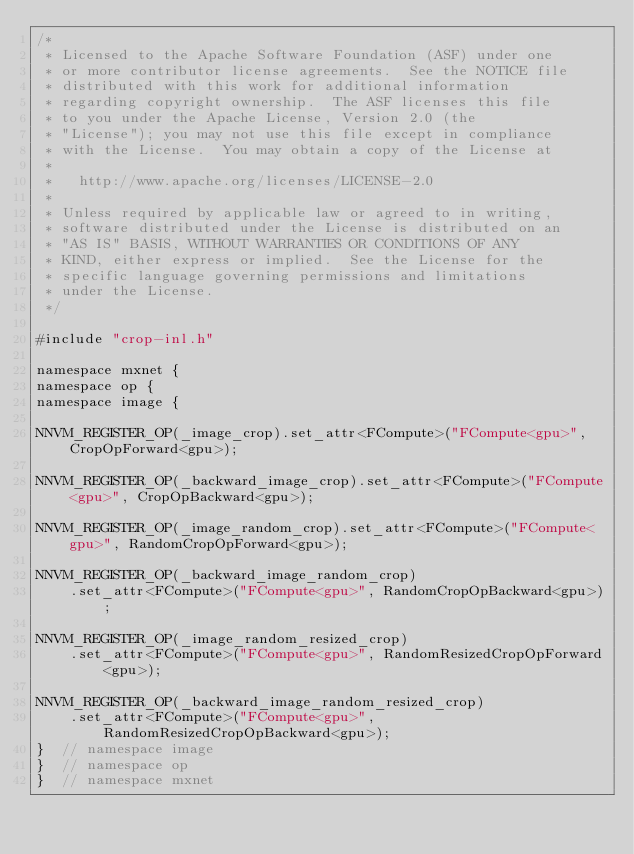<code> <loc_0><loc_0><loc_500><loc_500><_Cuda_>/*
 * Licensed to the Apache Software Foundation (ASF) under one
 * or more contributor license agreements.  See the NOTICE file
 * distributed with this work for additional information
 * regarding copyright ownership.  The ASF licenses this file
 * to you under the Apache License, Version 2.0 (the
 * "License"); you may not use this file except in compliance
 * with the License.  You may obtain a copy of the License at
 *
 *   http://www.apache.org/licenses/LICENSE-2.0
 *
 * Unless required by applicable law or agreed to in writing,
 * software distributed under the License is distributed on an
 * "AS IS" BASIS, WITHOUT WARRANTIES OR CONDITIONS OF ANY
 * KIND, either express or implied.  See the License for the
 * specific language governing permissions and limitations
 * under the License.
 */

#include "crop-inl.h"

namespace mxnet {
namespace op {
namespace image {

NNVM_REGISTER_OP(_image_crop).set_attr<FCompute>("FCompute<gpu>", CropOpForward<gpu>);

NNVM_REGISTER_OP(_backward_image_crop).set_attr<FCompute>("FCompute<gpu>", CropOpBackward<gpu>);

NNVM_REGISTER_OP(_image_random_crop).set_attr<FCompute>("FCompute<gpu>", RandomCropOpForward<gpu>);

NNVM_REGISTER_OP(_backward_image_random_crop)
    .set_attr<FCompute>("FCompute<gpu>", RandomCropOpBackward<gpu>);

NNVM_REGISTER_OP(_image_random_resized_crop)
    .set_attr<FCompute>("FCompute<gpu>", RandomResizedCropOpForward<gpu>);

NNVM_REGISTER_OP(_backward_image_random_resized_crop)
    .set_attr<FCompute>("FCompute<gpu>", RandomResizedCropOpBackward<gpu>);
}  // namespace image
}  // namespace op
}  // namespace mxnet
</code> 